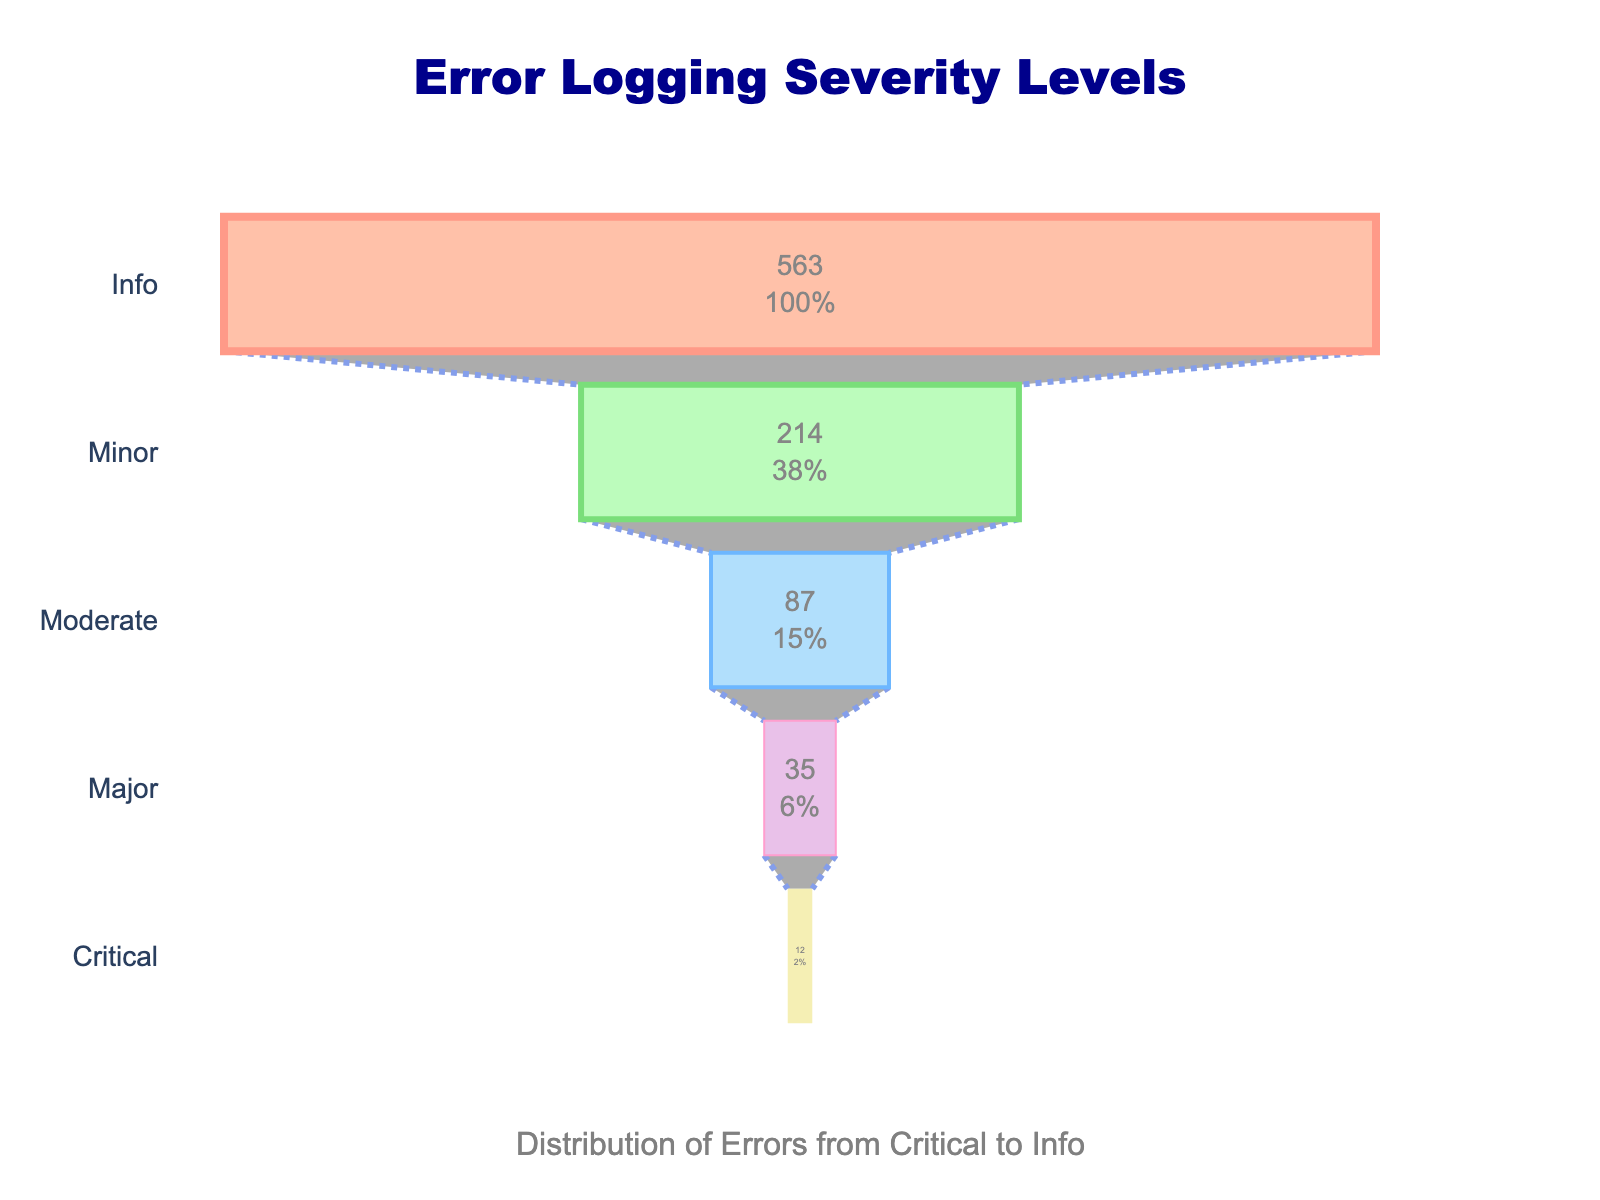What are the different severity levels shown in the funnel chart? The funnel chart displays severity levels along the y-axis. Observing the labels, the severity levels listed from top to bottom are Critical, Major, Moderate, Minor, and Info.
Answer: Critical, Major, Moderate, Minor, Info What is the total number of errors distributed across all severity levels? To find the total number, sum the counts of all severity levels: Critical (12) + Major (35) + Moderate (87) + Minor (214) + Info (563). Adding these together gives 911.
Answer: 911 Which severity level has the highest count of errors? The chart shows the width of each section proportional to the count. The Info section is the widest, indicating it has the highest count. The label confirms it with 563 errors.
Answer: Info How many more errors are in the Moderate level compared to the Critical level? Subtract the count for Critical (12) from Moderate (87). This results in 87 - 12 = 75 more errors in the Moderate level.
Answer: 75 What percentage of the initial total is made up by Major errors? The chart shows the percentage for each level. Major errors are shown as 3.8% of the initial total.
Answer: 3.8% Compare the counts of Minor and Major errors. How many times greater is the number of Minor errors as compared to Major errors? Divide the Minor error count (214) by the Major error count (35). This calculation gives 214 / 35 = 6.11. So, the number of Minor errors is about 6.11 times greater than Major errors.
Answer: 6.11 What is the combined error count of Critical and Major severity levels? Add the counts for Critical (12) and Major (35) together. The sum is 12 + 35 = 47.
Answer: 47 What proportion of errors are of Moderate severity compared to the overall total? The chart specifies each section's percent of the initial total. For Moderate errors, the chart indicates 9.5%.
Answer: 9.5% What severity level has the fewest errors? The funnel chart's smallest section represents the level with the fewest errors, which is Critical, as indicated by the label of 12 errors.
Answer: Critical If you were to combine Minor and Info errors, what percentage of the total errors would this combined group represent? Sum the counts for Minor (214) and Info (563) to get 777. To find the percentage among the total (911), calculate (777 / 911) * 100 ≈ 85.3%.
Answer: 85.3% 